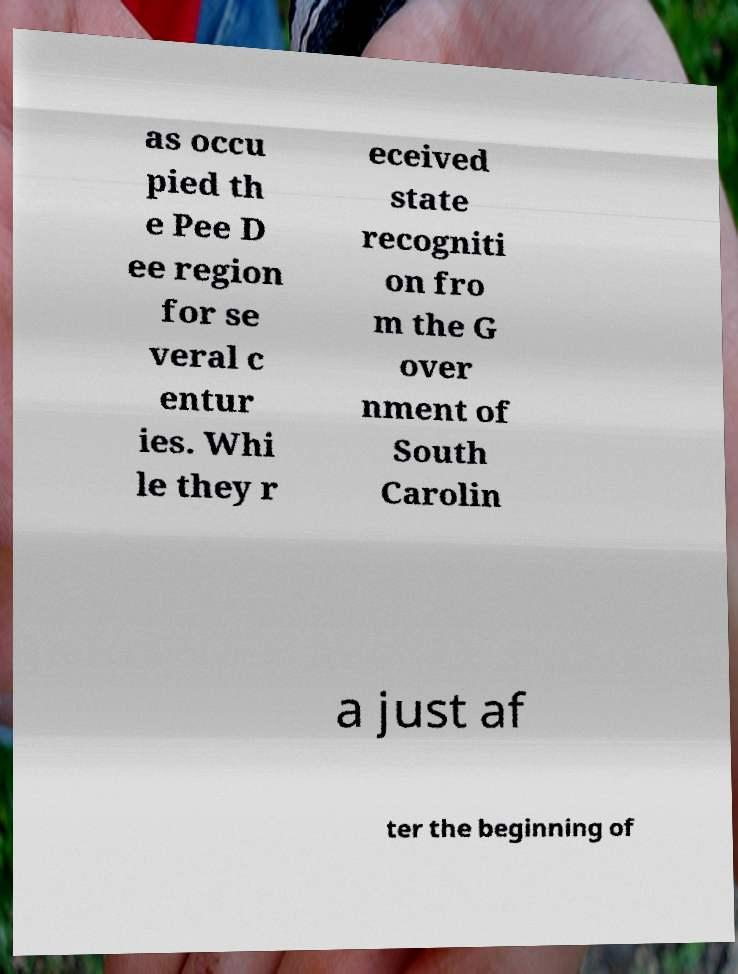Please read and relay the text visible in this image. What does it say? as occu pied th e Pee D ee region for se veral c entur ies. Whi le they r eceived state recogniti on fro m the G over nment of South Carolin a just af ter the beginning of 